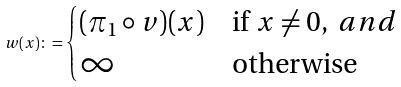Convert formula to latex. <formula><loc_0><loc_0><loc_500><loc_500>w ( x ) \colon = \begin{cases} ( \pi _ { 1 } \circ v ) ( x ) & \text {if } x \neq 0 , \ a n d \\ \infty & \text {otherwise } \end{cases}</formula> 